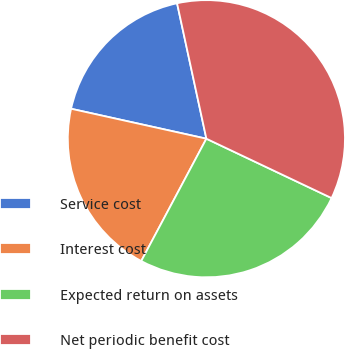Convert chart to OTSL. <chart><loc_0><loc_0><loc_500><loc_500><pie_chart><fcel>Service cost<fcel>Interest cost<fcel>Expected return on assets<fcel>Net periodic benefit cost<nl><fcel>18.14%<fcel>20.68%<fcel>25.74%<fcel>35.44%<nl></chart> 